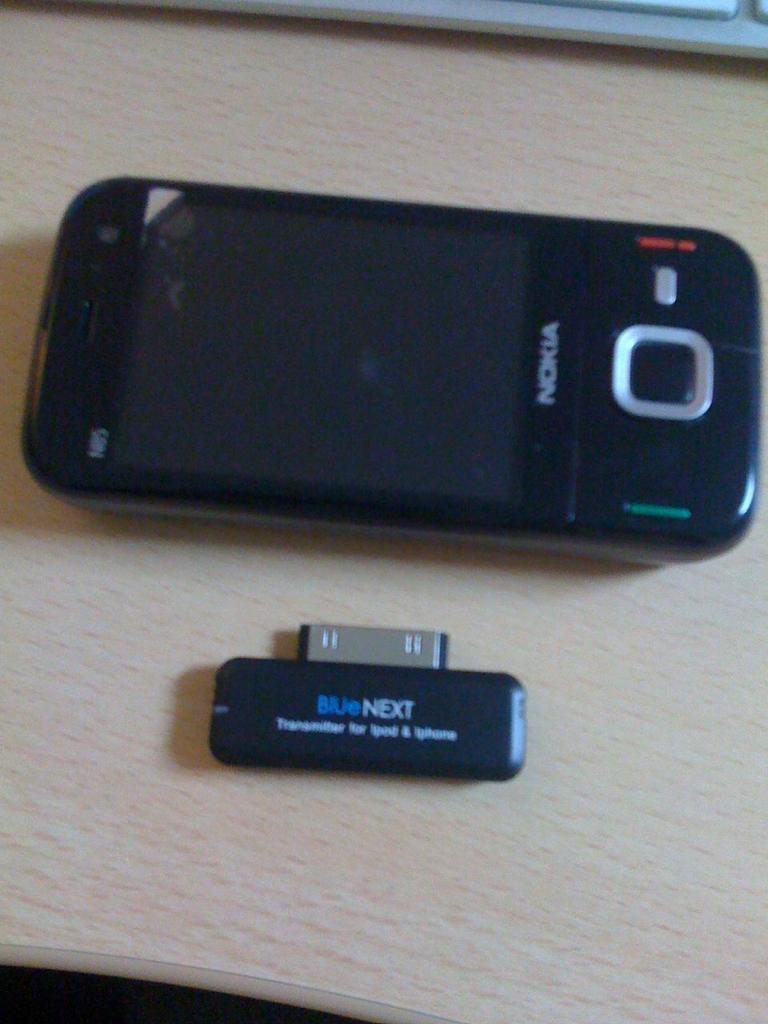What brand phone is this?
Make the answer very short. Nokia. What word is written in blue on the small device?
Provide a short and direct response. Blue. 